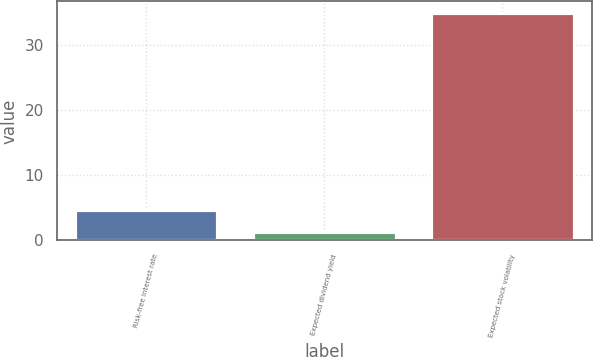<chart> <loc_0><loc_0><loc_500><loc_500><bar_chart><fcel>Risk-free interest rate<fcel>Expected dividend yield<fcel>Expected stock volatility<nl><fcel>4.58<fcel>1.2<fcel>35<nl></chart> 